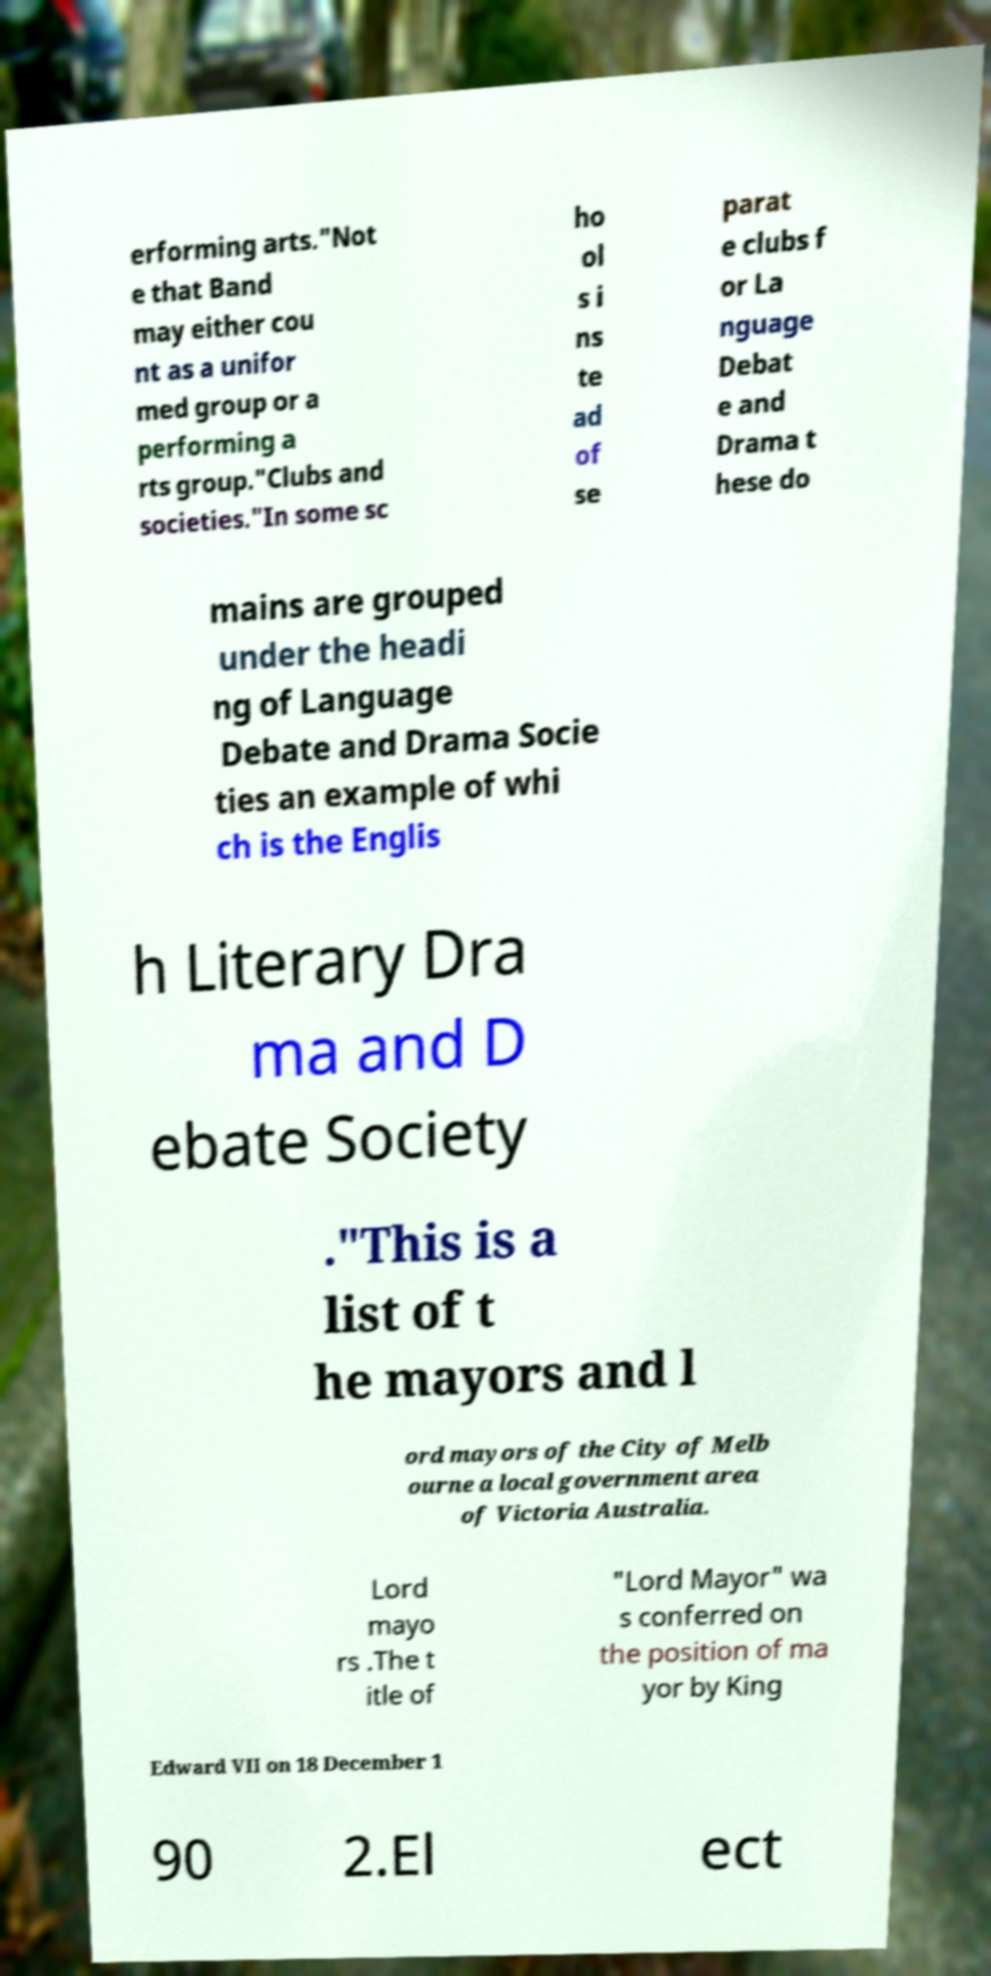Could you extract and type out the text from this image? erforming arts."Not e that Band may either cou nt as a unifor med group or a performing a rts group."Clubs and societies."In some sc ho ol s i ns te ad of se parat e clubs f or La nguage Debat e and Drama t hese do mains are grouped under the headi ng of Language Debate and Drama Socie ties an example of whi ch is the Englis h Literary Dra ma and D ebate Society ."This is a list of t he mayors and l ord mayors of the City of Melb ourne a local government area of Victoria Australia. Lord mayo rs .The t itle of "Lord Mayor" wa s conferred on the position of ma yor by King Edward VII on 18 December 1 90 2.El ect 